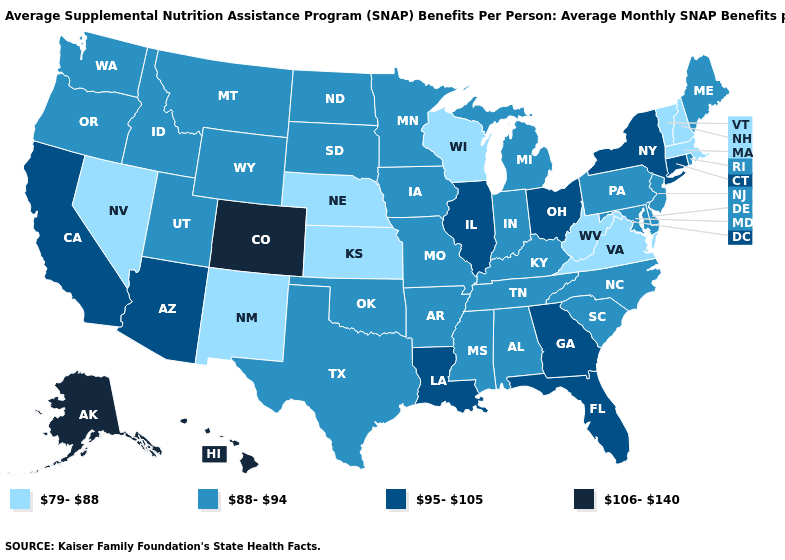Does Nebraska have a lower value than New Mexico?
Keep it brief. No. Which states have the lowest value in the Northeast?
Be succinct. Massachusetts, New Hampshire, Vermont. Does Colorado have the highest value in the USA?
Short answer required. Yes. Is the legend a continuous bar?
Keep it brief. No. Name the states that have a value in the range 106-140?
Write a very short answer. Alaska, Colorado, Hawaii. What is the highest value in the USA?
Concise answer only. 106-140. Name the states that have a value in the range 106-140?
Be succinct. Alaska, Colorado, Hawaii. Does Arkansas have the lowest value in the USA?
Concise answer only. No. What is the highest value in the West ?
Give a very brief answer. 106-140. What is the value of Massachusetts?
Write a very short answer. 79-88. What is the value of Connecticut?
Give a very brief answer. 95-105. Among the states that border Montana , which have the highest value?
Give a very brief answer. Idaho, North Dakota, South Dakota, Wyoming. Among the states that border Alabama , does Mississippi have the lowest value?
Keep it brief. Yes. Among the states that border Wyoming , which have the highest value?
Be succinct. Colorado. Name the states that have a value in the range 95-105?
Quick response, please. Arizona, California, Connecticut, Florida, Georgia, Illinois, Louisiana, New York, Ohio. 